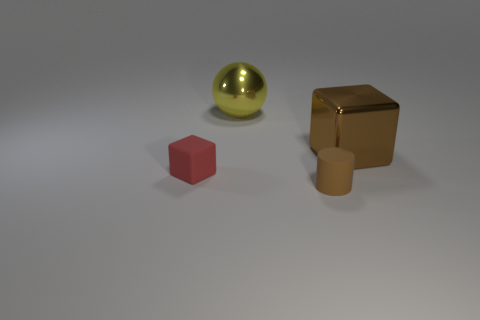What number of other objects are the same color as the cylinder?
Make the answer very short. 1. Do the object that is in front of the red rubber block and the large sphere have the same color?
Provide a succinct answer. No. Do the cube left of the metallic sphere and the large yellow sphere have the same material?
Your answer should be compact. No. What is the material of the brown object that is behind the brown cylinder?
Make the answer very short. Metal. There is a metal thing behind the brown shiny thing behind the tiny brown matte object; how big is it?
Keep it short and to the point. Large. What number of shiny spheres are the same size as the brown shiny block?
Provide a succinct answer. 1. Does the small thing that is on the right side of the yellow metal thing have the same color as the small thing that is behind the tiny brown matte cylinder?
Ensure brevity in your answer.  No. Are there any large brown cubes in front of the large brown cube?
Give a very brief answer. No. There is a object that is right of the matte cube and to the left of the tiny matte cylinder; what color is it?
Your response must be concise. Yellow. Are there any cylinders that have the same color as the metallic cube?
Ensure brevity in your answer.  Yes. 